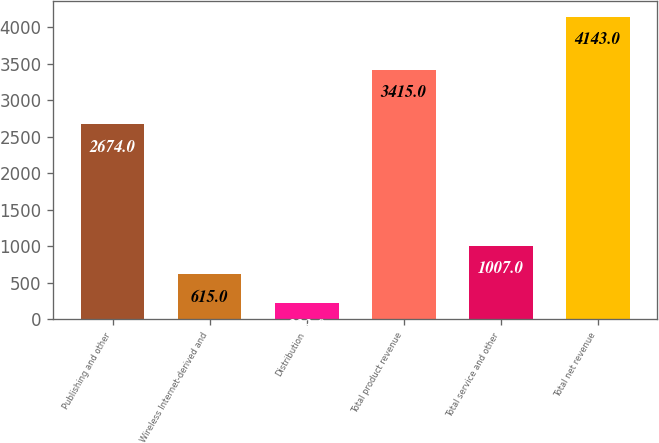<chart> <loc_0><loc_0><loc_500><loc_500><bar_chart><fcel>Publishing and other<fcel>Wireless Internet-derived and<fcel>Distribution<fcel>Total product revenue<fcel>Total service and other<fcel>Total net revenue<nl><fcel>2674<fcel>615<fcel>223<fcel>3415<fcel>1007<fcel>4143<nl></chart> 